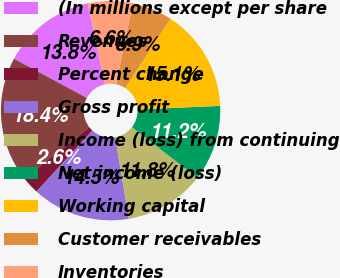<chart> <loc_0><loc_0><loc_500><loc_500><pie_chart><fcel>(In millions except per share<fcel>Revenues<fcel>Percent change<fcel>Gross profit<fcel>Income (loss) from continuing<fcel>Net income (loss)<fcel>Working capital<fcel>Customer receivables<fcel>Inventories<nl><fcel>13.82%<fcel>18.42%<fcel>2.63%<fcel>14.47%<fcel>11.84%<fcel>11.18%<fcel>15.13%<fcel>5.92%<fcel>6.58%<nl></chart> 